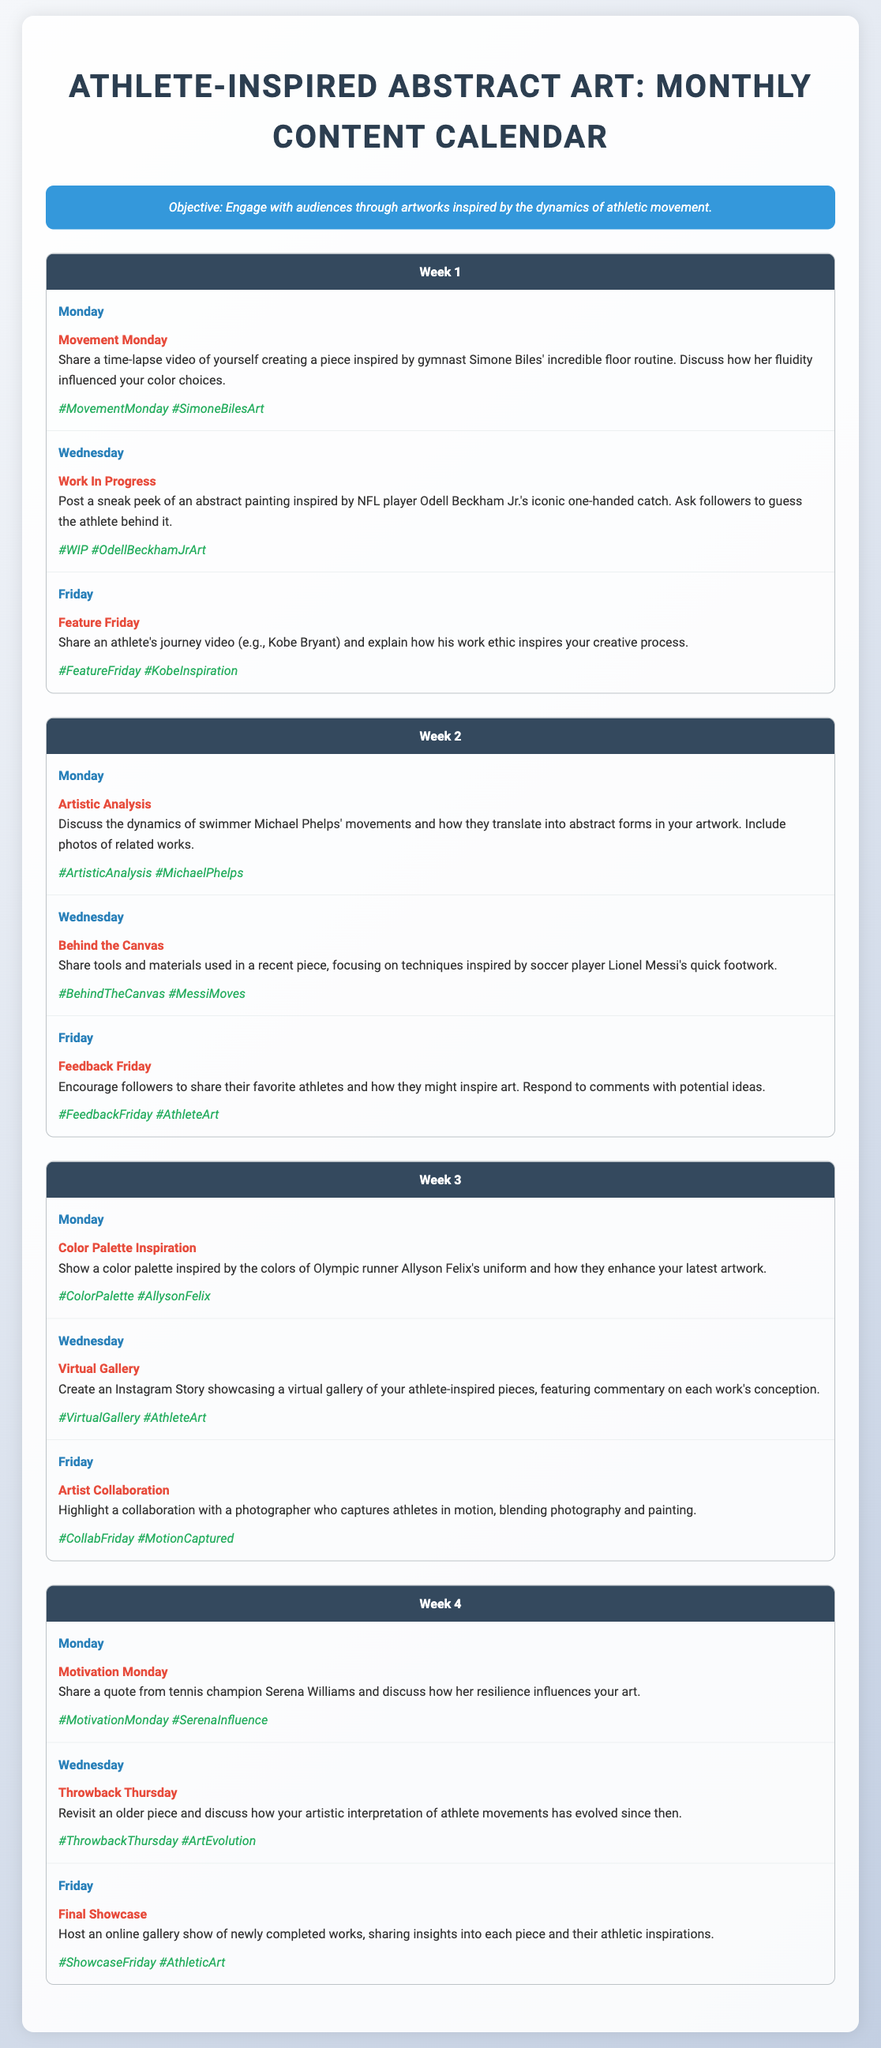What is the objective of the content calendar? The objective section clearly states the intention behind the calendar, which is to engage with audiences through artworks inspired by athletic movement dynamics.
Answer: Engage with audiences through artworks inspired by the dynamics of athletic movement How many weeks are outlined in the content calendar? The document is structured into four distinct weeks, each having its own set of posts.
Answer: 4 Which athlete inspires the "Movement Monday" post in Week 1? The post content specifically mentions gymnast Simone Biles as the inspiration for this particular post.
Answer: Simone Biles What day features a post about tools and materials used in a painting? The "Behind the Canvas" post about tools and materials appears on Wednesday of Week 2.
Answer: Wednesday Which post encourages followers to share their favorite athletes? The "Feedback Friday" post from Week 2 invites followers to share and discuss their favorite athletes.
Answer: Feedback Friday What sport does Odell Beckham Jr. play? The document includes a post inspired by Odell Beckham Jr., who is known for playing in the NFL.
Answer: NFL What type of content is featured in the "Final Showcase"? The "Final Showcase" post indicates that it will host an online gallery show of newly completed works.
Answer: Online gallery show Which athlete is referenced in the "Motivation Monday" post? The document specifies that a quote from tennis champion Serena Williams is being shared in this post.
Answer: Serena Williams What is shared on the "Virtual Gallery" day? The "Virtual Gallery" post involves creating an Instagram Story to showcase a virtual gallery of athlete-inspired pieces.
Answer: Instagram Story showcasing a virtual gallery 